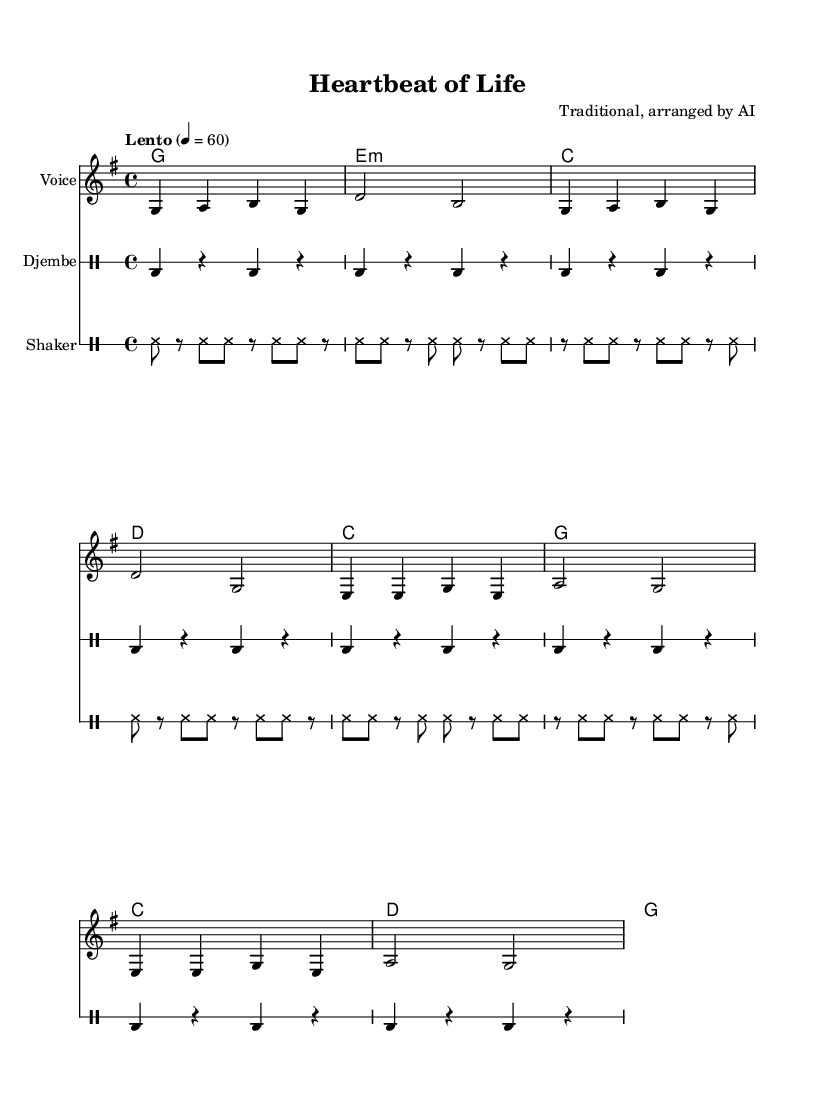What is the key signature of this music? The key signature indicated at the beginning of the score is G major, which has one sharp (F#).
Answer: G major What is the time signature of the piece? The time signature displayed at the start of the music is 4/4, meaning there are four beats in each measure and the quarter note receives one beat.
Answer: 4/4 What is the tempo marking of this composition? The tempo marking states "Lento" with a metronome marking of quarter note equals 60, indicating a slow pace.
Answer: Lento How many measures are in the vocal line? The vocal line is divided into eight measures, as seen by counting the vertical bar lines separating the musical phrases.
Answer: Eight What rhythmic elements in the percussion mimic fetal heartbeats? The djembe part consists of a repeating bass drum rhythm that creates a steady pulse, echoing the consistency of a fetal heartbeat.
Answer: Bass drum rhythm What is the lyrical theme of this lullaby? The lyrics reflect themes of love, comfort, and peaceful sleep for a child, characterized by gentle rhythms and nurturing imagery.
Answer: Love and comfort Which instruments are included in this score? The score features a voice for the melody, djembe for rhythm, and a shaker for additional percussive texture.
Answer: Voice, djembe, shaker 